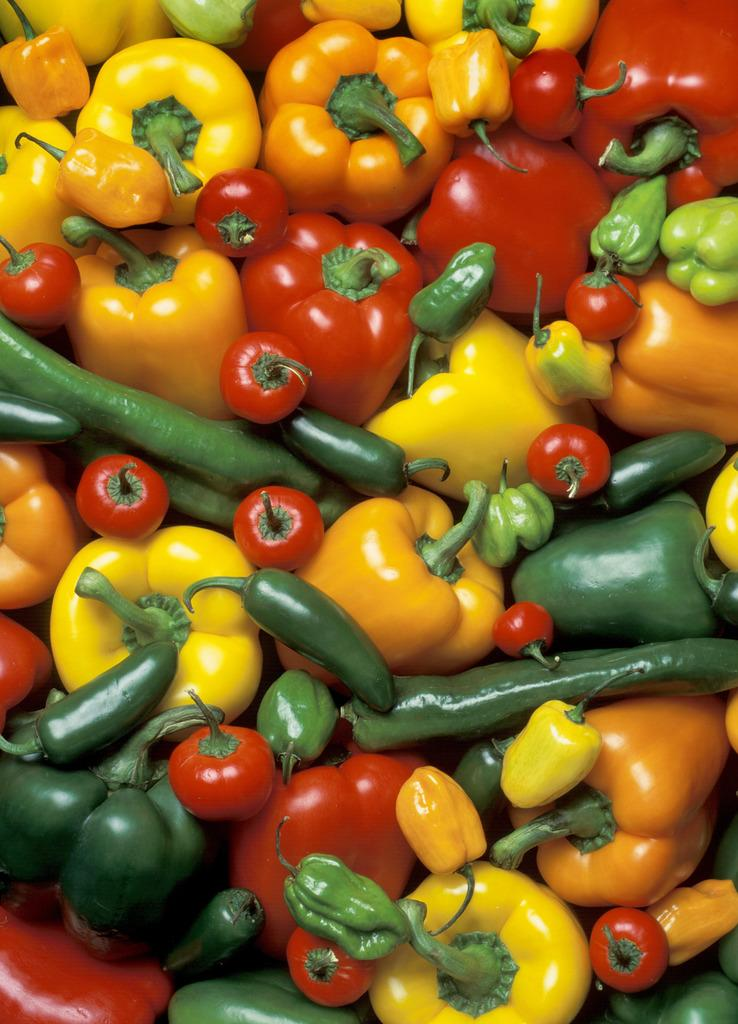What type of vegetables are present in the image? There are capsicums and green chilies in the image. Can you describe the color of the capsicums? The capsicums in the image are not described by color, but they are present. Are there any other vegetables or fruits visible in the image? The facts provided only mention capsicums and green chilies, so no other vegetables or fruits are mentioned. What type of wine is being served by the doctor in the image? There is no wine, doctor, or any serving action present in the image. The image only contains capsicums and green chilies. 